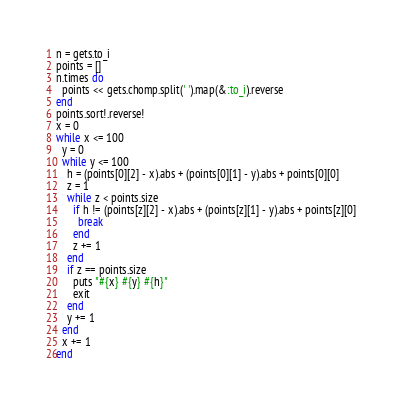<code> <loc_0><loc_0><loc_500><loc_500><_Ruby_>n = gets.to_i
points = []
n.times do
  points << gets.chomp.split(' ').map(&:to_i).reverse
end
points.sort!.reverse!
x = 0
while x <= 100
  y = 0
  while y <= 100
    h = (points[0][2] - x).abs + (points[0][1] - y).abs + points[0][0]
    z = 1
    while z < points.size
      if h != (points[z][2] - x).abs + (points[z][1] - y).abs + points[z][0]
        break
      end
      z += 1
    end
    if z == points.size
      puts "#{x} #{y} #{h}"
      exit
    end
    y += 1
  end
  x += 1
end</code> 